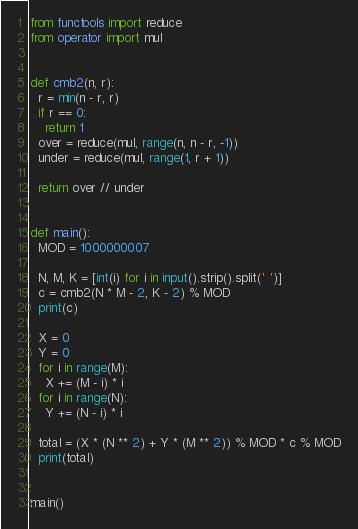Convert code to text. <code><loc_0><loc_0><loc_500><loc_500><_Python_>from functools import reduce
from operator import mul


def cmb2(n, r):
  r = min(n - r, r)
  if r == 0:
    return 1
  over = reduce(mul, range(n, n - r, -1))
  under = reduce(mul, range(1, r + 1))

  return over // under


def main():
  MOD = 1000000007

  N, M, K = [int(i) for i in input().strip().split(' ')]
  c = cmb2(N * M - 2, K - 2) % MOD
  print(c)

  X = 0
  Y = 0
  for i in range(M):
    X += (M - i) * i
  for i in range(N):
    Y += (N - i) * i

  total = (X * (N ** 2) + Y * (M ** 2)) % MOD * c % MOD
  print(total)


main()</code> 